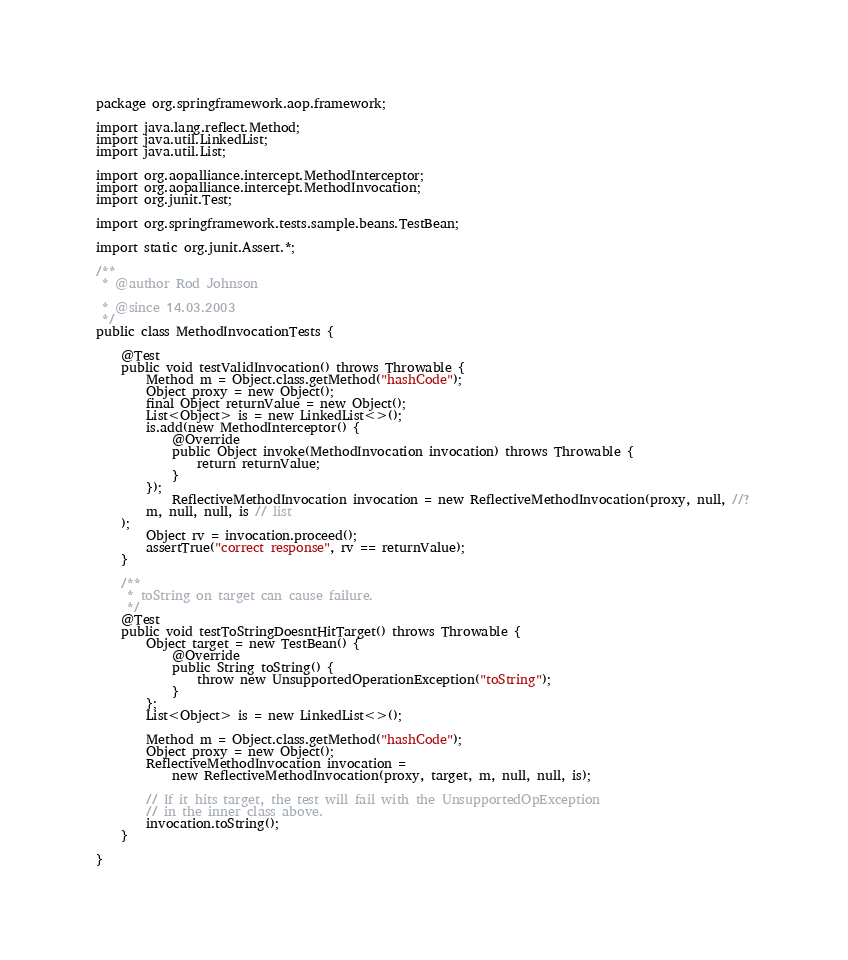Convert code to text. <code><loc_0><loc_0><loc_500><loc_500><_Java_>

package org.springframework.aop.framework;

import java.lang.reflect.Method;
import java.util.LinkedList;
import java.util.List;

import org.aopalliance.intercept.MethodInterceptor;
import org.aopalliance.intercept.MethodInvocation;
import org.junit.Test;

import org.springframework.tests.sample.beans.TestBean;

import static org.junit.Assert.*;

/**
 * @author Rod Johnson

 * @since 14.03.2003
 */
public class MethodInvocationTests {

	@Test
	public void testValidInvocation() throws Throwable {
		Method m = Object.class.getMethod("hashCode");
		Object proxy = new Object();
		final Object returnValue = new Object();
		List<Object> is = new LinkedList<>();
		is.add(new MethodInterceptor() {
			@Override
			public Object invoke(MethodInvocation invocation) throws Throwable {
				return returnValue;
			}
		});
			ReflectiveMethodInvocation invocation = new ReflectiveMethodInvocation(proxy, null, //?
		m, null, null, is // list
	);
		Object rv = invocation.proceed();
		assertTrue("correct response", rv == returnValue);
	}

	/**
	 * toString on target can cause failure.
	 */
	@Test
	public void testToStringDoesntHitTarget() throws Throwable {
		Object target = new TestBean() {
			@Override
			public String toString() {
				throw new UnsupportedOperationException("toString");
			}
		};
		List<Object> is = new LinkedList<>();

		Method m = Object.class.getMethod("hashCode");
		Object proxy = new Object();
		ReflectiveMethodInvocation invocation =
			new ReflectiveMethodInvocation(proxy, target, m, null, null, is);

		// If it hits target, the test will fail with the UnsupportedOpException
		// in the inner class above.
		invocation.toString();
	}

}
</code> 